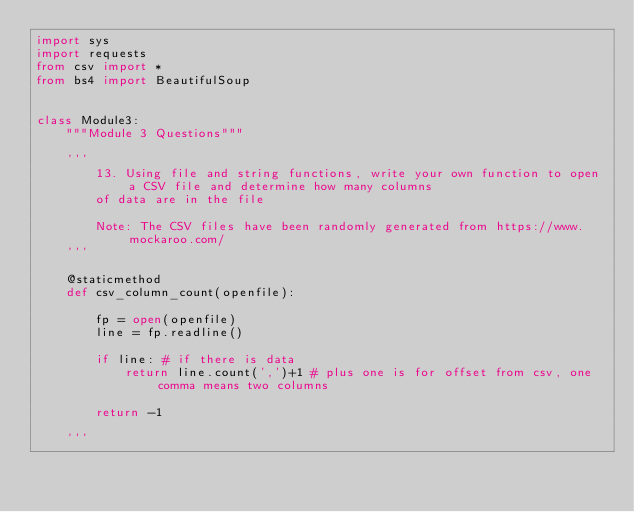<code> <loc_0><loc_0><loc_500><loc_500><_Python_>import sys
import requests
from csv import *
from bs4 import BeautifulSoup


class Module3:
    """Module 3 Questions"""

    '''
        13. Using file and string functions, write your own function to open a CSV file and determine how many columns
        of data are in the file

        Note: The CSV files have been randomly generated from https://www.mockaroo.com/
    '''

    @staticmethod
    def csv_column_count(openfile):

        fp = open(openfile)
        line = fp.readline()

        if line: # if there is data
            return line.count(',')+1 # plus one is for offset from csv, one comma means two columns

        return -1

    '''</code> 